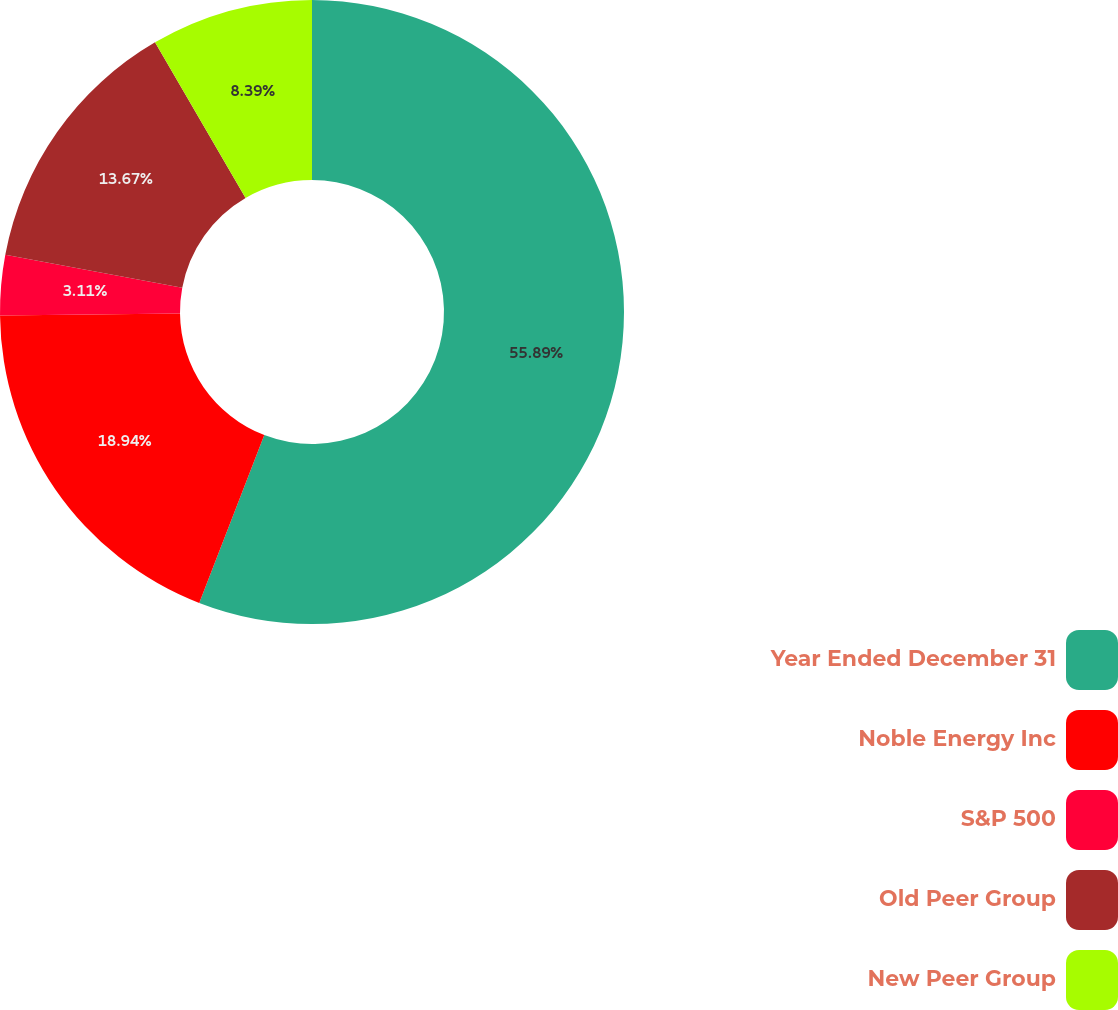Convert chart to OTSL. <chart><loc_0><loc_0><loc_500><loc_500><pie_chart><fcel>Year Ended December 31<fcel>Noble Energy Inc<fcel>S&P 500<fcel>Old Peer Group<fcel>New Peer Group<nl><fcel>55.88%<fcel>18.94%<fcel>3.11%<fcel>13.67%<fcel>8.39%<nl></chart> 